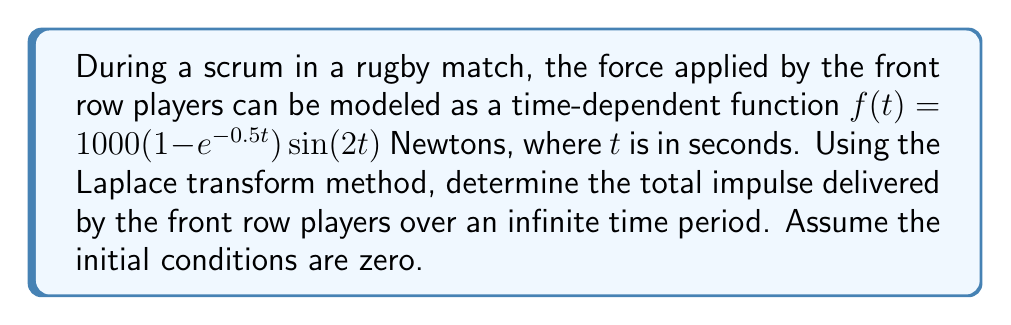Can you answer this question? To solve this problem, we'll follow these steps:

1) First, recall that the Laplace transform of $f(t)$ is defined as:

   $$F(s) = \mathcal{L}\{f(t)\} = \int_0^\infty f(t)e^{-st}dt$$

2) The impulse is the integral of force over time. In the s-domain, this is equivalent to dividing $F(s)$ by $s$. So, we need to find $F(s)$ and then divide by $s$.

3) Let's break down $f(t)$ into two parts:
   
   $f(t) = 1000(1 - e^{-0.5t})\sin(2t) = 1000\sin(2t) - 1000e^{-0.5t}\sin(2t)$

4) We can use the Laplace transform of $\sin(at)$: $\mathcal{L}\{\sin(at)\} = \frac{a}{s^2+a^2}$

5) For the second term, we can use the shifting property of Laplace transforms:
   $\mathcal{L}\{e^{-at}g(t)\} = G(s+a)$

6) Applying these:

   $$F(s) = 1000\cdot\frac{2}{s^2+4} - 1000\cdot\frac{2}{(s+0.5)^2+4}$$

7) To find the total impulse, we divide by $s$:

   $$I(s) = \frac{F(s)}{s} = 1000\cdot\frac{2}{s(s^2+4)} - 1000\cdot\frac{2}{s((s+0.5)^2+4)}$$

8) The total impulse over infinite time is given by the limit of $I(s)$ as $s$ approaches 0:

   $$\text{Total Impulse} = \lim_{s\to0} sI(s) = 1000\cdot\frac{2}{4} - 1000\cdot\frac{2}{4.25} = 500 - 470.59 = 29.41$$
Answer: The total impulse delivered by the front row players over an infinite time period is approximately 29.41 Newton-seconds. 